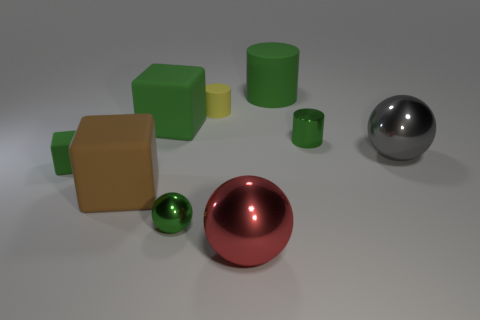How many objects are either large cylinders or gray cylinders?
Offer a very short reply. 1. There is a metallic thing that is to the right of the large red ball and in front of the metallic cylinder; what size is it?
Ensure brevity in your answer.  Large. What number of gray things have the same material as the red thing?
Your answer should be very brief. 1. What color is the large cube that is the same material as the brown object?
Offer a very short reply. Green. There is a tiny rubber object that is in front of the big gray metallic sphere; does it have the same color as the tiny metal cylinder?
Provide a succinct answer. Yes. There is a big cube right of the big brown rubber block; what is its material?
Your answer should be compact. Rubber. Are there the same number of tiny green metallic cylinders behind the large cylinder and big red metallic objects?
Make the answer very short. No. How many other cylinders have the same color as the large rubber cylinder?
Your response must be concise. 1. There is another big thing that is the same shape as the brown rubber object; what color is it?
Offer a terse response. Green. Does the red thing have the same size as the metallic cylinder?
Your answer should be very brief. No. 